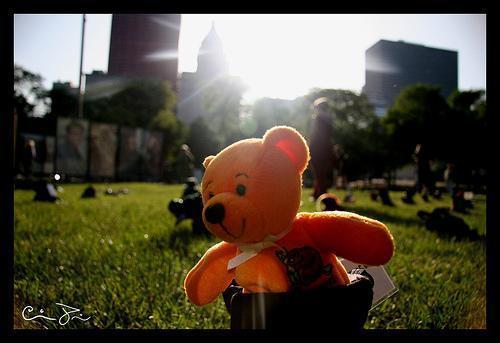How many bears are there?
Give a very brief answer. 1. 